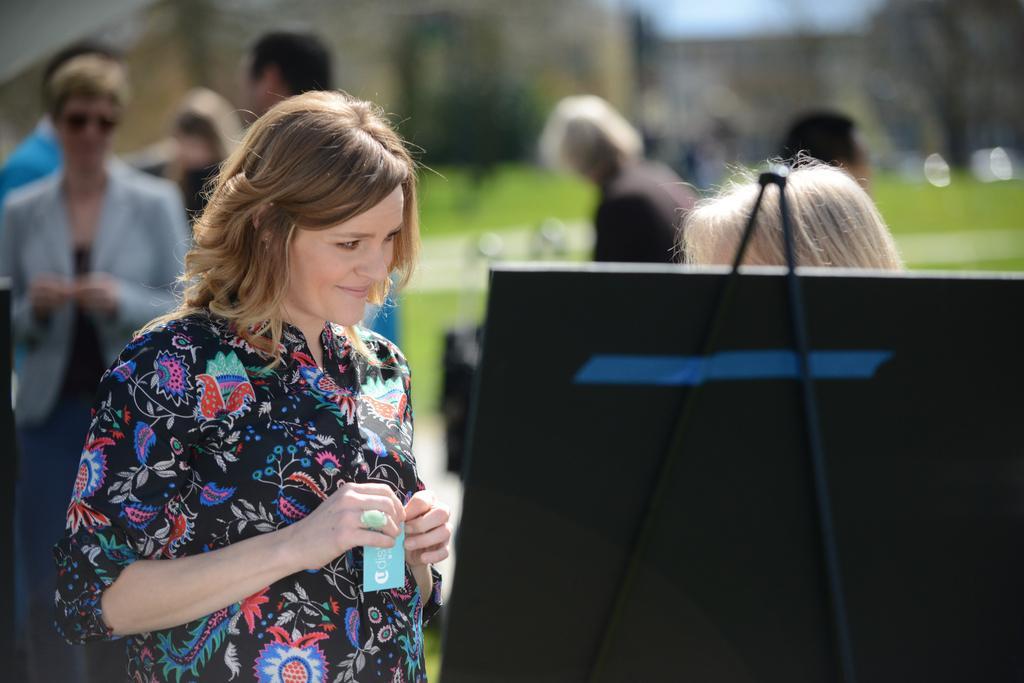Please provide a concise description of this image. In the image we can see a woman standing, wearing clothes, finger ring and she is smiling, she is holding a paper in her hand. Behind her we can see there are many other people standing, wearing clothes and the background is blurred. 